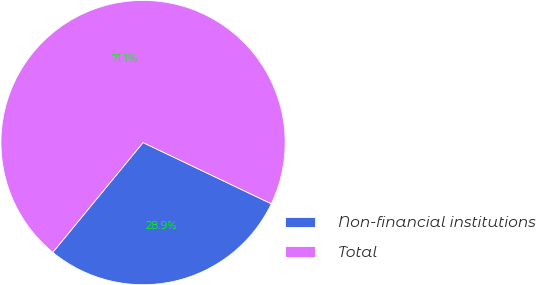Convert chart. <chart><loc_0><loc_0><loc_500><loc_500><pie_chart><fcel>Non-financial institutions<fcel>Total<nl><fcel>28.86%<fcel>71.14%<nl></chart> 